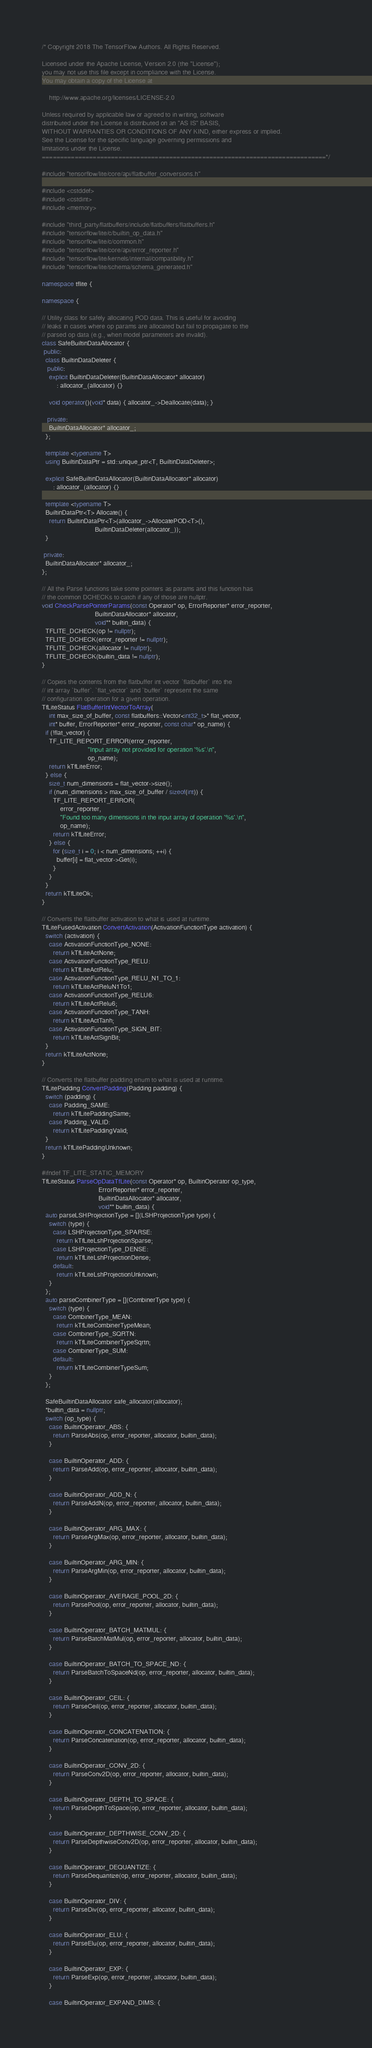<code> <loc_0><loc_0><loc_500><loc_500><_C++_>/* Copyright 2018 The TensorFlow Authors. All Rights Reserved.

Licensed under the Apache License, Version 2.0 (the "License");
you may not use this file except in compliance with the License.
You may obtain a copy of the License at

    http://www.apache.org/licenses/LICENSE-2.0

Unless required by applicable law or agreed to in writing, software
distributed under the License is distributed on an "AS IS" BASIS,
WITHOUT WARRANTIES OR CONDITIONS OF ANY KIND, either express or implied.
See the License for the specific language governing permissions and
limitations under the License.
==============================================================================*/

#include "tensorflow/lite/core/api/flatbuffer_conversions.h"

#include <cstddef>
#include <cstdint>
#include <memory>

#include "third_party/flatbuffers/include/flatbuffers/flatbuffers.h"
#include "tensorflow/lite/c/builtin_op_data.h"
#include "tensorflow/lite/c/common.h"
#include "tensorflow/lite/core/api/error_reporter.h"
#include "tensorflow/lite/kernels/internal/compatibility.h"
#include "tensorflow/lite/schema/schema_generated.h"

namespace tflite {

namespace {

// Utility class for safely allocating POD data. This is useful for avoiding
// leaks in cases where op params are allocated but fail to propagate to the
// parsed op data (e.g., when model parameters are invalid).
class SafeBuiltinDataAllocator {
 public:
  class BuiltinDataDeleter {
   public:
    explicit BuiltinDataDeleter(BuiltinDataAllocator* allocator)
        : allocator_(allocator) {}

    void operator()(void* data) { allocator_->Deallocate(data); }

   private:
    BuiltinDataAllocator* allocator_;
  };

  template <typename T>
  using BuiltinDataPtr = std::unique_ptr<T, BuiltinDataDeleter>;

  explicit SafeBuiltinDataAllocator(BuiltinDataAllocator* allocator)
      : allocator_(allocator) {}

  template <typename T>
  BuiltinDataPtr<T> Allocate() {
    return BuiltinDataPtr<T>(allocator_->AllocatePOD<T>(),
                             BuiltinDataDeleter(allocator_));
  }

 private:
  BuiltinDataAllocator* allocator_;
};

// All the Parse functions take some pointers as params and this function has
// the common DCHECKs to catch if any of those are nullptr.
void CheckParsePointerParams(const Operator* op, ErrorReporter* error_reporter,
                             BuiltinDataAllocator* allocator,
                             void** builtin_data) {
  TFLITE_DCHECK(op != nullptr);
  TFLITE_DCHECK(error_reporter != nullptr);
  TFLITE_DCHECK(allocator != nullptr);
  TFLITE_DCHECK(builtin_data != nullptr);
}

// Copies the contents from the flatbuffer int vector `flatbuffer` into the
// int array `buffer`. `flat_vector` and `buffer` represent the same
// configuration operation for a given operation.
TfLiteStatus FlatBufferIntVectorToArray(
    int max_size_of_buffer, const flatbuffers::Vector<int32_t>* flat_vector,
    int* buffer, ErrorReporter* error_reporter, const char* op_name) {
  if (!flat_vector) {
    TF_LITE_REPORT_ERROR(error_reporter,
                         "Input array not provided for operation '%s'.\n",
                         op_name);
    return kTfLiteError;
  } else {
    size_t num_dimensions = flat_vector->size();
    if (num_dimensions > max_size_of_buffer / sizeof(int)) {
      TF_LITE_REPORT_ERROR(
          error_reporter,
          "Found too many dimensions in the input array of operation '%s'.\n",
          op_name);
      return kTfLiteError;
    } else {
      for (size_t i = 0; i < num_dimensions; ++i) {
        buffer[i] = flat_vector->Get(i);
      }
    }
  }
  return kTfLiteOk;
}

// Converts the flatbuffer activation to what is used at runtime.
TfLiteFusedActivation ConvertActivation(ActivationFunctionType activation) {
  switch (activation) {
    case ActivationFunctionType_NONE:
      return kTfLiteActNone;
    case ActivationFunctionType_RELU:
      return kTfLiteActRelu;
    case ActivationFunctionType_RELU_N1_TO_1:
      return kTfLiteActReluN1To1;
    case ActivationFunctionType_RELU6:
      return kTfLiteActRelu6;
    case ActivationFunctionType_TANH:
      return kTfLiteActTanh;
    case ActivationFunctionType_SIGN_BIT:
      return kTfLiteActSignBit;
  }
  return kTfLiteActNone;
}

// Converts the flatbuffer padding enum to what is used at runtime.
TfLitePadding ConvertPadding(Padding padding) {
  switch (padding) {
    case Padding_SAME:
      return kTfLitePaddingSame;
    case Padding_VALID:
      return kTfLitePaddingValid;
  }
  return kTfLitePaddingUnknown;
}

#ifndef TF_LITE_STATIC_MEMORY
TfLiteStatus ParseOpDataTfLite(const Operator* op, BuiltinOperator op_type,
                               ErrorReporter* error_reporter,
                               BuiltinDataAllocator* allocator,
                               void** builtin_data) {
  auto parseLSHProjectionType = [](LSHProjectionType type) {
    switch (type) {
      case LSHProjectionType_SPARSE:
        return kTfLiteLshProjectionSparse;
      case LSHProjectionType_DENSE:
        return kTfLiteLshProjectionDense;
      default:
        return kTfLiteLshProjectionUnknown;
    }
  };
  auto parseCombinerType = [](CombinerType type) {
    switch (type) {
      case CombinerType_MEAN:
        return kTfLiteCombinerTypeMean;
      case CombinerType_SQRTN:
        return kTfLiteCombinerTypeSqrtn;
      case CombinerType_SUM:
      default:
        return kTfLiteCombinerTypeSum;
    }
  };

  SafeBuiltinDataAllocator safe_allocator(allocator);
  *builtin_data = nullptr;
  switch (op_type) {
    case BuiltinOperator_ABS: {
      return ParseAbs(op, error_reporter, allocator, builtin_data);
    }

    case BuiltinOperator_ADD: {
      return ParseAdd(op, error_reporter, allocator, builtin_data);
    }

    case BuiltinOperator_ADD_N: {
      return ParseAddN(op, error_reporter, allocator, builtin_data);
    }

    case BuiltinOperator_ARG_MAX: {
      return ParseArgMax(op, error_reporter, allocator, builtin_data);
    }

    case BuiltinOperator_ARG_MIN: {
      return ParseArgMin(op, error_reporter, allocator, builtin_data);
    }

    case BuiltinOperator_AVERAGE_POOL_2D: {
      return ParsePool(op, error_reporter, allocator, builtin_data);
    }

    case BuiltinOperator_BATCH_MATMUL: {
      return ParseBatchMatMul(op, error_reporter, allocator, builtin_data);
    }

    case BuiltinOperator_BATCH_TO_SPACE_ND: {
      return ParseBatchToSpaceNd(op, error_reporter, allocator, builtin_data);
    }

    case BuiltinOperator_CEIL: {
      return ParseCeil(op, error_reporter, allocator, builtin_data);
    }

    case BuiltinOperator_CONCATENATION: {
      return ParseConcatenation(op, error_reporter, allocator, builtin_data);
    }

    case BuiltinOperator_CONV_2D: {
      return ParseConv2D(op, error_reporter, allocator, builtin_data);
    }

    case BuiltinOperator_DEPTH_TO_SPACE: {
      return ParseDepthToSpace(op, error_reporter, allocator, builtin_data);
    }

    case BuiltinOperator_DEPTHWISE_CONV_2D: {
      return ParseDepthwiseConv2D(op, error_reporter, allocator, builtin_data);
    }

    case BuiltinOperator_DEQUANTIZE: {
      return ParseDequantize(op, error_reporter, allocator, builtin_data);
    }

    case BuiltinOperator_DIV: {
      return ParseDiv(op, error_reporter, allocator, builtin_data);
    }

    case BuiltinOperator_ELU: {
      return ParseElu(op, error_reporter, allocator, builtin_data);
    }

    case BuiltinOperator_EXP: {
      return ParseExp(op, error_reporter, allocator, builtin_data);
    }

    case BuiltinOperator_EXPAND_DIMS: {</code> 